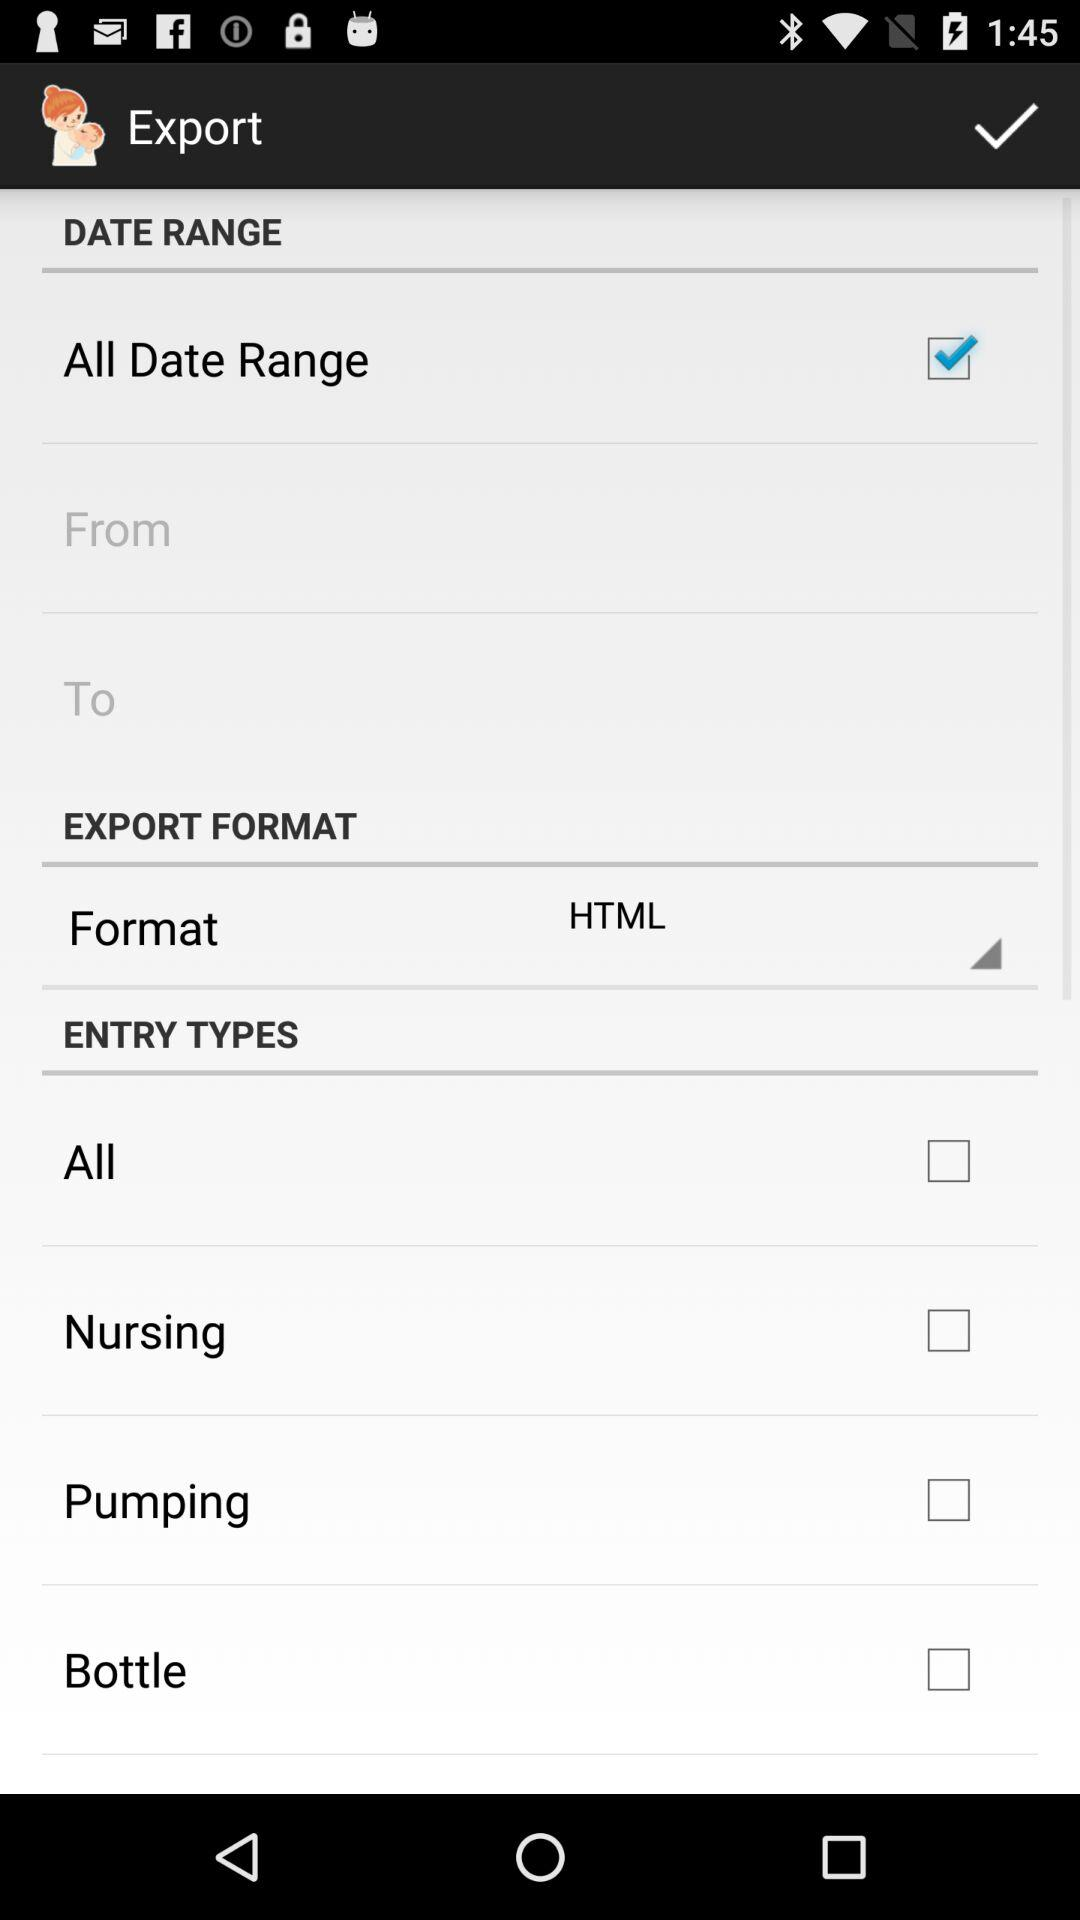What are the entry types? The entry types are "All", "Nursing", "Pumping", and "Bottle". 